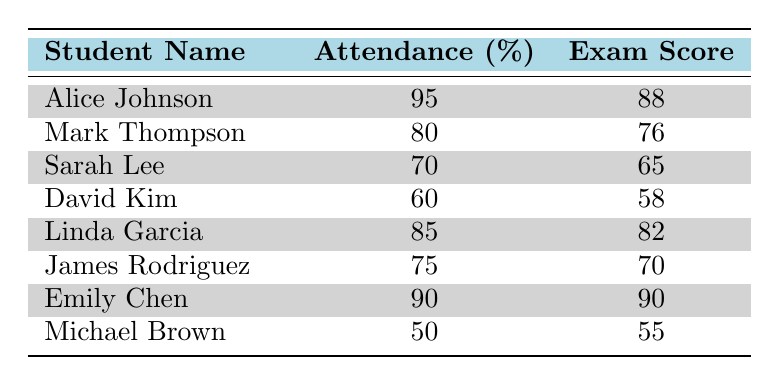What is the exam score of Emily Chen? In the table, under the column "Student Name," locate "Emily Chen." The corresponding exam score, found in the same row under the column "Exam Score," is 90.
Answer: 90 What is the attendance percentage of Linda Garcia? To find Linda Garcia's attendance percentage, look for her name in the "Student Name" column and check the same row under the "Attendance (%)" column, which shows 85.
Answer: 85 Who has the highest attendance percentage? The highest attendance percentage can be identified by comparing all percentages listed in the “Attendance (%)” column. Alice Johnson has the highest at 95%.
Answer: Alice Johnson Calculate the average exam score for all students. To calculate the average, sum the exam scores: 88 + 76 + 65 + 58 + 82 + 70 + 90 + 55 = 494, then divide by the number of students (8), resulting in 494 / 8 = 61.75.
Answer: 61.75 Is Sarah Lee's exam score above 70? Sarah Lee's exam score is 65, which is less than 70, so the statement is false.
Answer: No What is the difference between the highest and lowest exam scores? The highest exam score is 90 (Emily Chen), and the lowest is 55 (Michael Brown). The difference is calculated as 90 - 55 = 35.
Answer: 35 Does Mark Thompson have a higher attendance percentage than Linda Garcia? Mark Thompson's attendance percentage is 80, and Linda Garcia's is 85. Since 80 is less than 85, the statement is false.
Answer: No If you average the attendance percentages of students with scores above 70, what is the result? First, identify students with scores above 70: Alice Johnson (95% attendance), Mark Thompson (80%), Linda Garcia (85%), James Rodriguez (75%), and Emily Chen (90%). Their attendance percentages are 95, 80, 85, 75, and 90. The average is (95 + 80 + 85 + 75 + 90) / 5 = 85.
Answer: 85 Which student has the lowest attendance percentage? Review the "Attendance (%)" column to find the lowest percentage, which corresponds to Michael Brown at 50%.
Answer: Michael Brown 